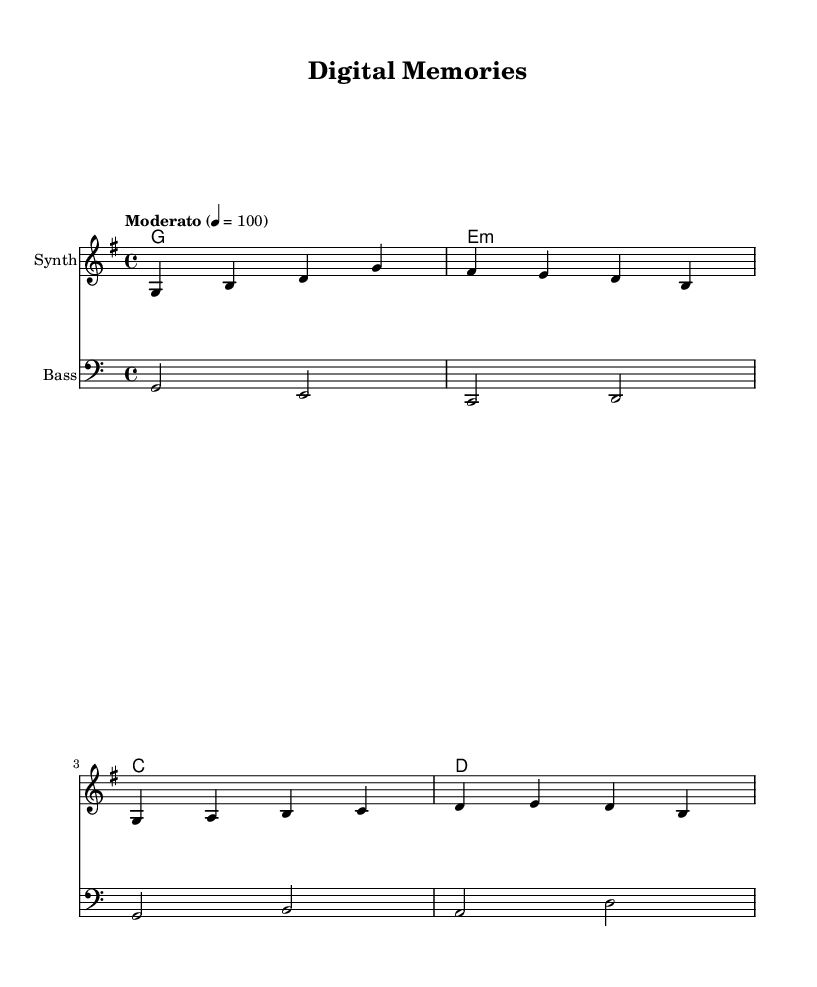What is the key signature of this music? The key signature is G major, which has one sharp (F#). We can determine this by looking at the key signature indicated at the beginning of the staff.
Answer: G major What is the time signature? The time signature is 4/4, which is shown at the beginning of the music. This means there are four beats in a measure and the quarter note gets one beat.
Answer: 4/4 What is the tempo marking? The tempo marking is Moderato, set at 100 beats per minute. This is indicated in the tempo directive, which specifies the speed of the piece.
Answer: Moderato How many measures are in the melody section? The melody section consists of four measures, which can be counted visually by looking at the grouping of note symbols in the melody staff.
Answer: Four Which chord is played in the second measure? The second measure features an E minor chord, identified by the chord notation at the beginning of the line, which indicates the harmonies being played.
Answer: E minor What instrument is indicated for the melody? The instrument indicated for the melody is "Synth," as seen in the instrument name label above the melody staff.
Answer: Synth How does the bass clef differ from the treble clef? The bass clef is used for lower pitch notes and is typically played by instruments like the bass guitar or cello, while the treble clef is for higher notes, generally played by instruments like the flute or violin. This distinction helps performers know which notes to play and their ranges.
Answer: Lower pitch 